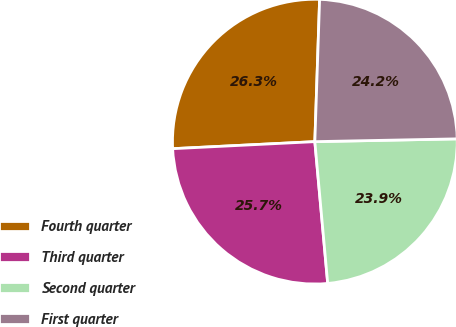Convert chart. <chart><loc_0><loc_0><loc_500><loc_500><pie_chart><fcel>Fourth quarter<fcel>Third quarter<fcel>Second quarter<fcel>First quarter<nl><fcel>26.32%<fcel>25.65%<fcel>23.87%<fcel>24.15%<nl></chart> 